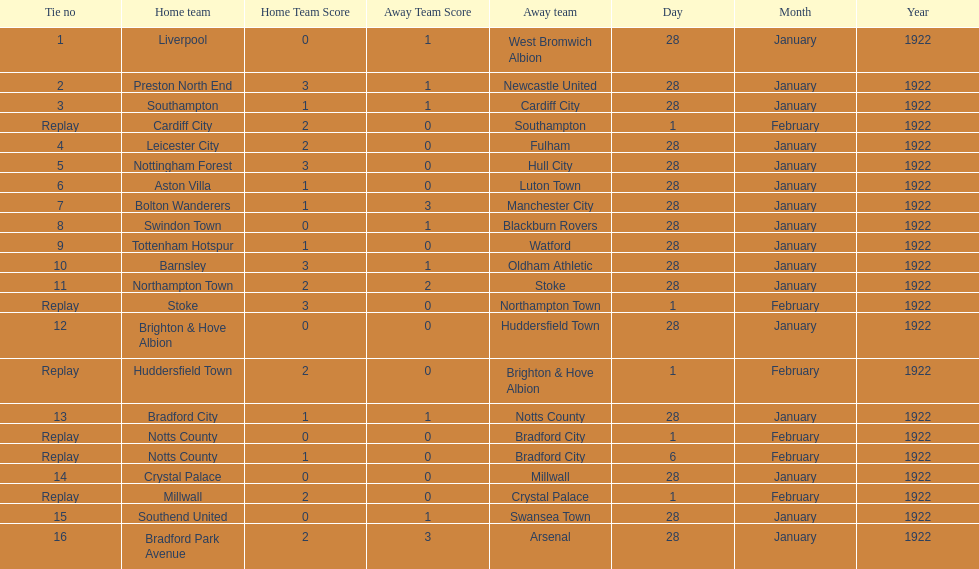Write the full table. {'header': ['Tie no', 'Home team', 'Home Team Score', 'Away Team Score', 'Away team', 'Day', 'Month', 'Year'], 'rows': [['1', 'Liverpool', '0', '1', 'West Bromwich Albion', '28', 'January', '1922'], ['2', 'Preston North End', '3', '1', 'Newcastle United', '28', 'January', '1922'], ['3', 'Southampton', '1', '1', 'Cardiff City', '28', 'January', '1922'], ['Replay', 'Cardiff City', '2', '0', 'Southampton', '1', 'February', '1922'], ['4', 'Leicester City', '2', '0', 'Fulham', '28', 'January', '1922'], ['5', 'Nottingham Forest', '3', '0', 'Hull City', '28', 'January', '1922'], ['6', 'Aston Villa', '1', '0', 'Luton Town', '28', 'January', '1922'], ['7', 'Bolton Wanderers', '1', '3', 'Manchester City', '28', 'January', '1922'], ['8', 'Swindon Town', '0', '1', 'Blackburn Rovers', '28', 'January', '1922'], ['9', 'Tottenham Hotspur', '1', '0', 'Watford', '28', 'January', '1922'], ['10', 'Barnsley', '3', '1', 'Oldham Athletic', '28', 'January', '1922'], ['11', 'Northampton Town', '2', '2', 'Stoke', '28', 'January', '1922'], ['Replay', 'Stoke', '3', '0', 'Northampton Town', '1', 'February', '1922'], ['12', 'Brighton & Hove Albion', '0', '0', 'Huddersfield Town', '28', 'January', '1922'], ['Replay', 'Huddersfield Town', '2', '0', 'Brighton & Hove Albion', '1', 'February', '1922'], ['13', 'Bradford City', '1', '1', 'Notts County', '28', 'January', '1922'], ['Replay', 'Notts County', '0', '0', 'Bradford City', '1', 'February', '1922'], ['Replay', 'Notts County', '1', '0', 'Bradford City', '6', 'February', '1922'], ['14', 'Crystal Palace', '0', '0', 'Millwall', '28', 'January', '1922'], ['Replay', 'Millwall', '2', '0', 'Crystal Palace', '1', 'February', '1922'], ['15', 'Southend United', '0', '1', 'Swansea Town', '28', 'January', '1922'], ['16', 'Bradford Park Avenue', '2', '3', 'Arsenal', '28', 'January', '1922']]} How many total points were scored in the second round proper? 45. 